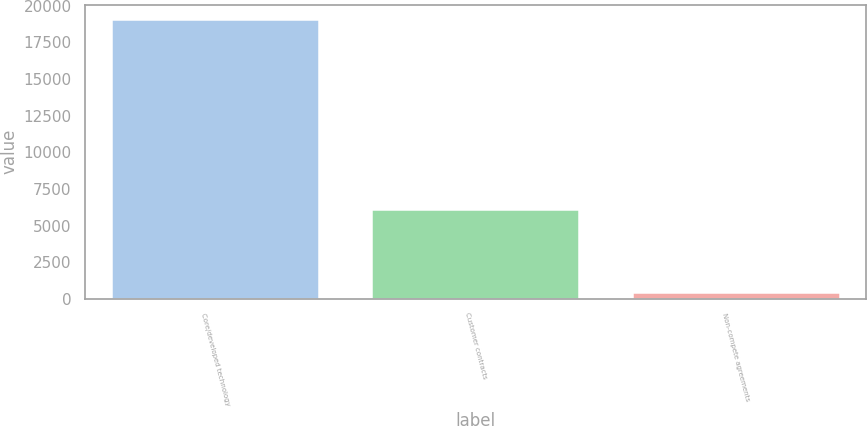<chart> <loc_0><loc_0><loc_500><loc_500><bar_chart><fcel>Core/developed technology<fcel>Customer contracts<fcel>Non-compete agreements<nl><fcel>19100<fcel>6100<fcel>500<nl></chart> 